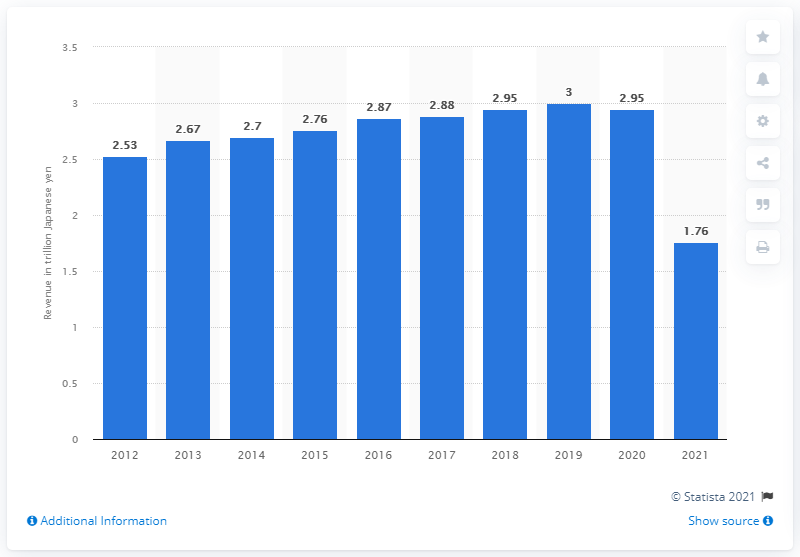Specify some key components in this picture. East Japan Railway Company's operating revenue in fiscal year 2021 was approximately 1.76 trillion yen. The operating revenue of East Japan Railway Company in the previous fiscal year was 2,950,000. 